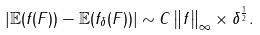Convert formula to latex. <formula><loc_0><loc_0><loc_500><loc_500>\left | { \mathbb { E } } ( f ( F ) ) - { \mathbb { E } } ( f _ { \delta } ( F ) ) \right | \sim C \left \| f \right \| _ { \infty } \times \delta ^ { \frac { 1 } { 2 } } .</formula> 